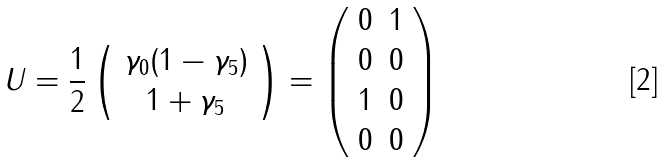Convert formula to latex. <formula><loc_0><loc_0><loc_500><loc_500>U = \frac { 1 } { 2 } \left ( \begin{array} { c } \gamma _ { 0 } ( 1 - \gamma _ { 5 } ) \\ 1 + \gamma _ { 5 } \end{array} \right ) = \left ( \begin{array} { c c } 0 & 1 \\ 0 & 0 \\ 1 & 0 \\ 0 & 0 \\ \end{array} \right )</formula> 